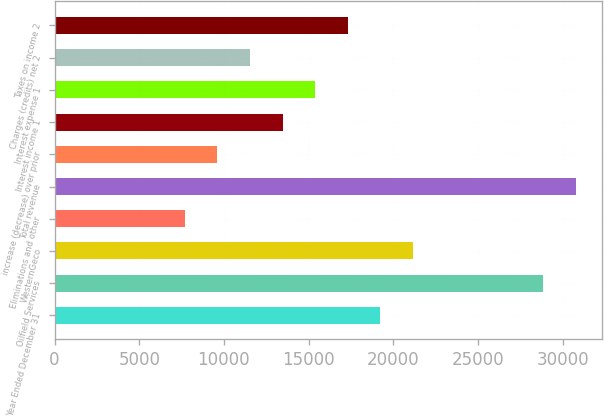<chart> <loc_0><loc_0><loc_500><loc_500><bar_chart><fcel>Year Ended December 31<fcel>Oilfield Services<fcel>WesternGeco<fcel>Eliminations and other<fcel>Total revenue<fcel>increase (decrease) over prior<fcel>Interest income 1<fcel>Interest expense 1<fcel>Charges (credits) net 2<fcel>Taxes on income 2<nl><fcel>19230<fcel>28844.8<fcel>21153<fcel>7692.3<fcel>30767.7<fcel>9615.25<fcel>13461.1<fcel>15384.1<fcel>11538.2<fcel>17307<nl></chart> 